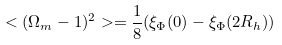<formula> <loc_0><loc_0><loc_500><loc_500>< ( \Omega _ { m } - 1 ) ^ { 2 } > = \frac { 1 } { 8 } ( \xi _ { \Phi } ( 0 ) - \xi _ { \Phi } ( 2 R _ { h } ) )</formula> 